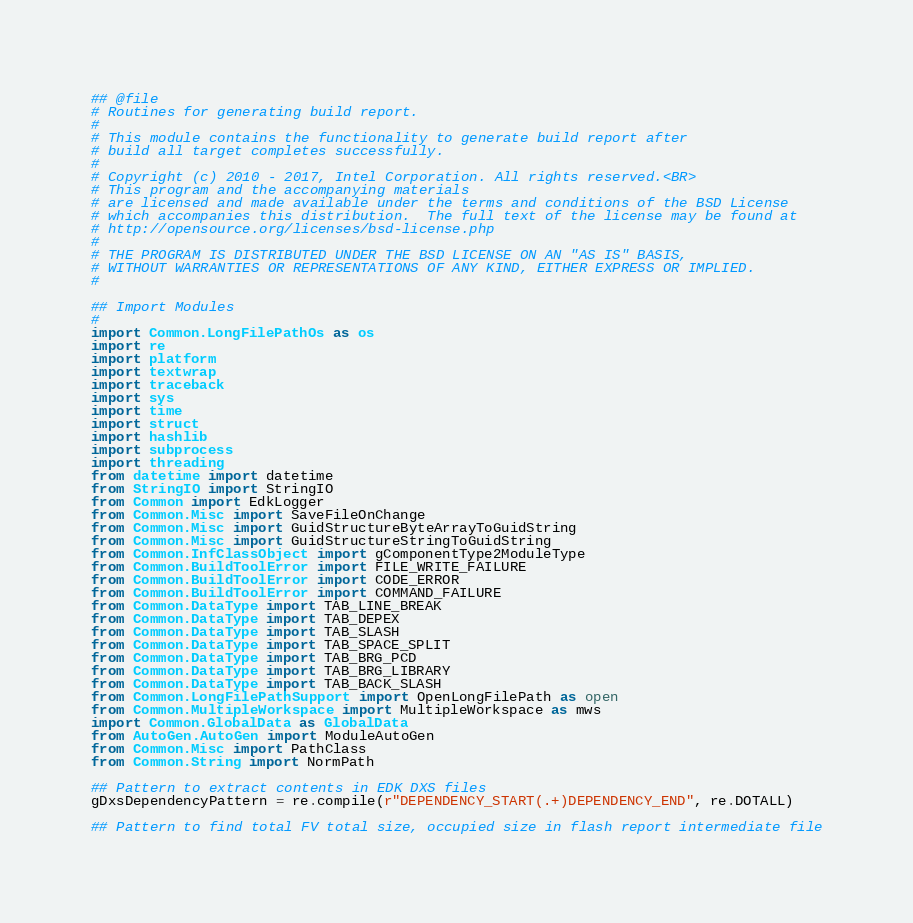Convert code to text. <code><loc_0><loc_0><loc_500><loc_500><_Python_>## @file
# Routines for generating build report.
#
# This module contains the functionality to generate build report after
# build all target completes successfully.
#
# Copyright (c) 2010 - 2017, Intel Corporation. All rights reserved.<BR>
# This program and the accompanying materials
# are licensed and made available under the terms and conditions of the BSD License
# which accompanies this distribution.  The full text of the license may be found at
# http://opensource.org/licenses/bsd-license.php
#
# THE PROGRAM IS DISTRIBUTED UNDER THE BSD LICENSE ON AN "AS IS" BASIS,
# WITHOUT WARRANTIES OR REPRESENTATIONS OF ANY KIND, EITHER EXPRESS OR IMPLIED.
#

## Import Modules
#
import Common.LongFilePathOs as os
import re
import platform
import textwrap
import traceback
import sys
import time
import struct
import hashlib
import subprocess
import threading
from datetime import datetime
from StringIO import StringIO
from Common import EdkLogger
from Common.Misc import SaveFileOnChange
from Common.Misc import GuidStructureByteArrayToGuidString
from Common.Misc import GuidStructureStringToGuidString
from Common.InfClassObject import gComponentType2ModuleType
from Common.BuildToolError import FILE_WRITE_FAILURE
from Common.BuildToolError import CODE_ERROR
from Common.BuildToolError import COMMAND_FAILURE
from Common.DataType import TAB_LINE_BREAK
from Common.DataType import TAB_DEPEX
from Common.DataType import TAB_SLASH
from Common.DataType import TAB_SPACE_SPLIT
from Common.DataType import TAB_BRG_PCD
from Common.DataType import TAB_BRG_LIBRARY
from Common.DataType import TAB_BACK_SLASH
from Common.LongFilePathSupport import OpenLongFilePath as open
from Common.MultipleWorkspace import MultipleWorkspace as mws
import Common.GlobalData as GlobalData
from AutoGen.AutoGen import ModuleAutoGen
from Common.Misc import PathClass
from Common.String import NormPath

## Pattern to extract contents in EDK DXS files
gDxsDependencyPattern = re.compile(r"DEPENDENCY_START(.+)DEPENDENCY_END", re.DOTALL)

## Pattern to find total FV total size, occupied size in flash report intermediate file</code> 